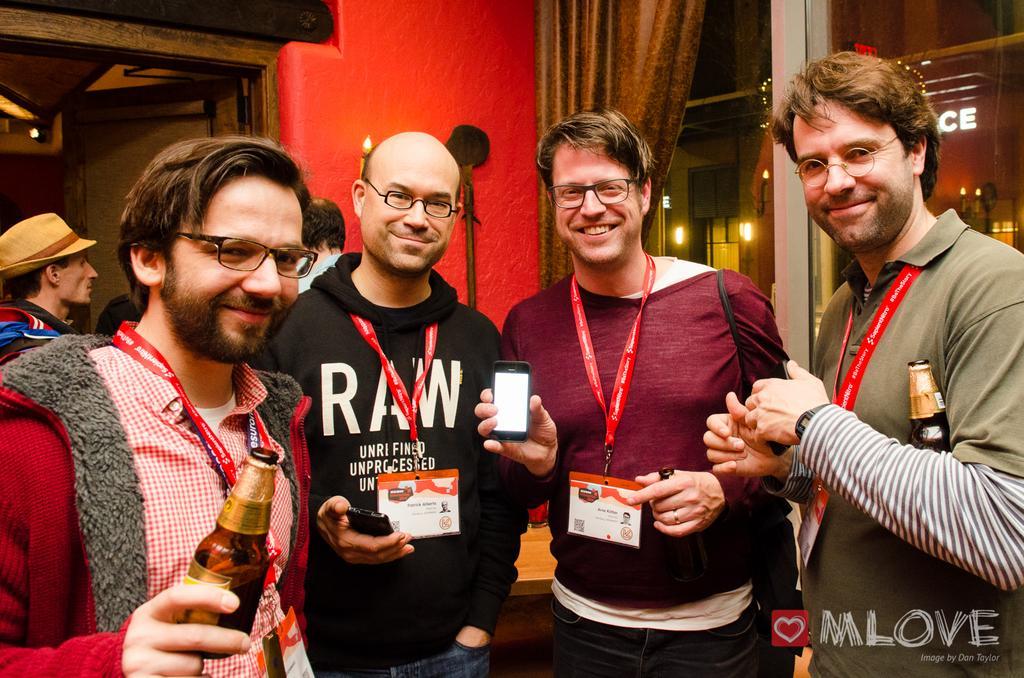Could you give a brief overview of what you see in this image? This 4 persons are standing. This 2 persons are holding a bottle. This person in red t-shirt is holding a mobile. This is curtain. The wall is in red color. Far there are lights. 